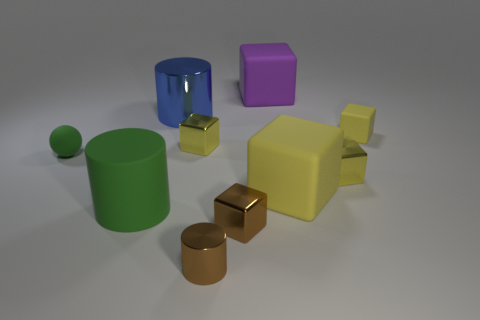There is a large object that is the same color as the tiny ball; what is its material?
Offer a very short reply. Rubber. The tiny metallic cylinder has what color?
Provide a succinct answer. Brown. How many things are brown shiny cylinders or large blocks?
Offer a very short reply. 3. There is a brown cylinder that is the same size as the green rubber sphere; what is its material?
Ensure brevity in your answer.  Metal. How big is the cube behind the blue metallic cylinder?
Keep it short and to the point. Large. What is the material of the blue cylinder?
Provide a short and direct response. Metal. How many things are small matte things in front of the small yellow matte block or yellow things that are behind the tiny sphere?
Your response must be concise. 3. What number of other objects are the same color as the ball?
Your answer should be compact. 1. Is the shape of the large purple thing the same as the brown metallic object in front of the brown metallic block?
Offer a very short reply. No. Is the number of small green things that are to the right of the green cylinder less than the number of balls in front of the rubber sphere?
Your response must be concise. No. 